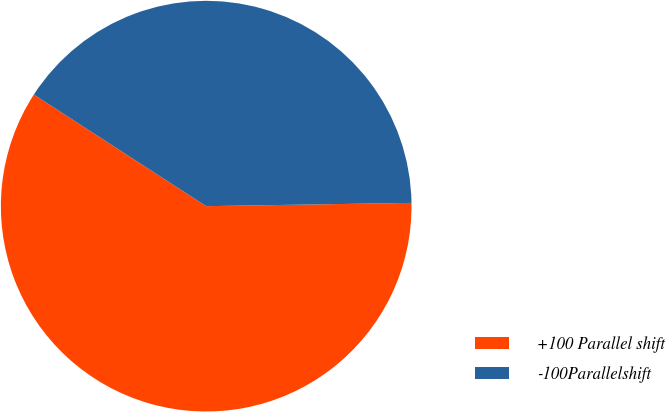<chart> <loc_0><loc_0><loc_500><loc_500><pie_chart><fcel>+100 Parallel shift<fcel>-100Parallelshift<nl><fcel>59.4%<fcel>40.6%<nl></chart> 